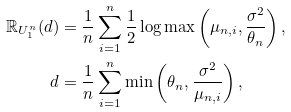Convert formula to latex. <formula><loc_0><loc_0><loc_500><loc_500>\mathbb { R } _ { U _ { 1 } ^ { n } } ( d ) & = \frac { 1 } { n } \sum _ { i = 1 } ^ { n } \frac { 1 } { 2 } \log \max \left ( \mu _ { n , i } , \frac { \sigma ^ { 2 } } { \theta _ { n } } \right ) , \\ d & = \frac { 1 } { n } \sum _ { i = 1 } ^ { n } \min \left ( \theta _ { n } , \frac { \sigma ^ { 2 } } { \mu _ { n , i } } \right ) ,</formula> 